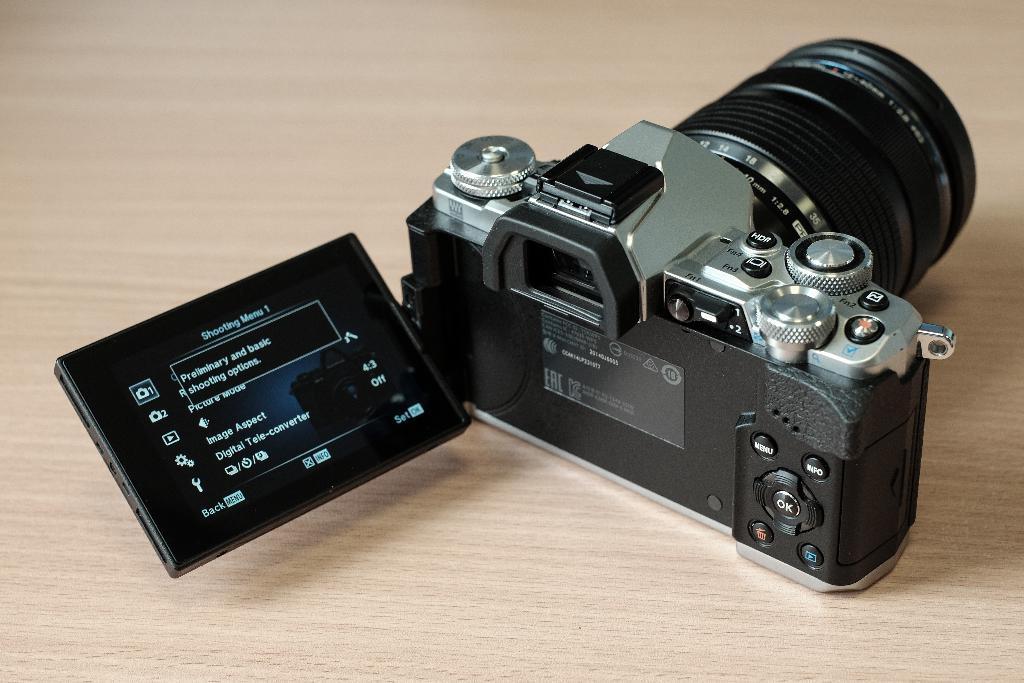In one or two sentences, can you explain what this image depicts? In the center of the image there is a camera on the table. 